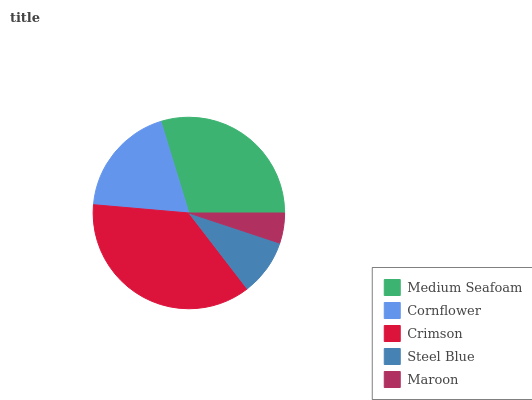Is Maroon the minimum?
Answer yes or no. Yes. Is Crimson the maximum?
Answer yes or no. Yes. Is Cornflower the minimum?
Answer yes or no. No. Is Cornflower the maximum?
Answer yes or no. No. Is Medium Seafoam greater than Cornflower?
Answer yes or no. Yes. Is Cornflower less than Medium Seafoam?
Answer yes or no. Yes. Is Cornflower greater than Medium Seafoam?
Answer yes or no. No. Is Medium Seafoam less than Cornflower?
Answer yes or no. No. Is Cornflower the high median?
Answer yes or no. Yes. Is Cornflower the low median?
Answer yes or no. Yes. Is Maroon the high median?
Answer yes or no. No. Is Steel Blue the low median?
Answer yes or no. No. 